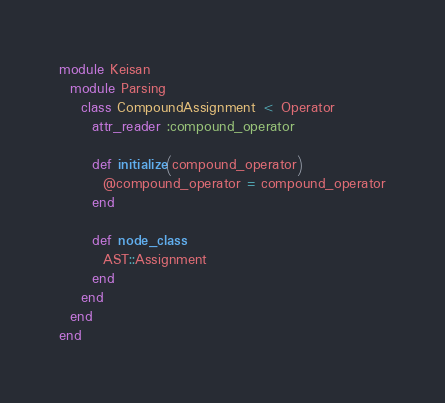Convert code to text. <code><loc_0><loc_0><loc_500><loc_500><_Ruby_>module Keisan
  module Parsing
    class CompoundAssignment < Operator
      attr_reader :compound_operator

      def initialize(compound_operator)
        @compound_operator = compound_operator
      end

      def node_class
        AST::Assignment
      end
    end
  end
end
</code> 